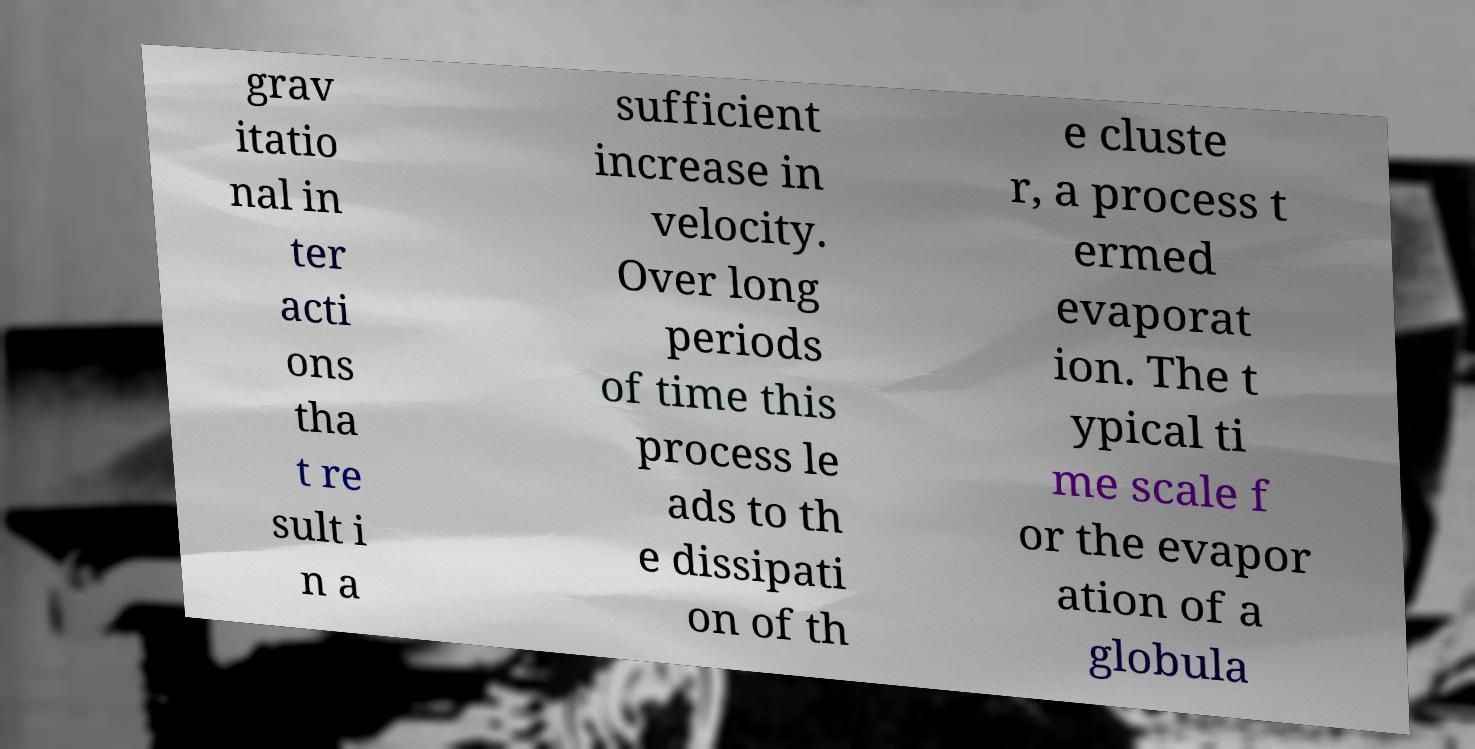There's text embedded in this image that I need extracted. Can you transcribe it verbatim? grav itatio nal in ter acti ons tha t re sult i n a sufficient increase in velocity. Over long periods of time this process le ads to th e dissipati on of th e cluste r, a process t ermed evaporat ion. The t ypical ti me scale f or the evapor ation of a globula 